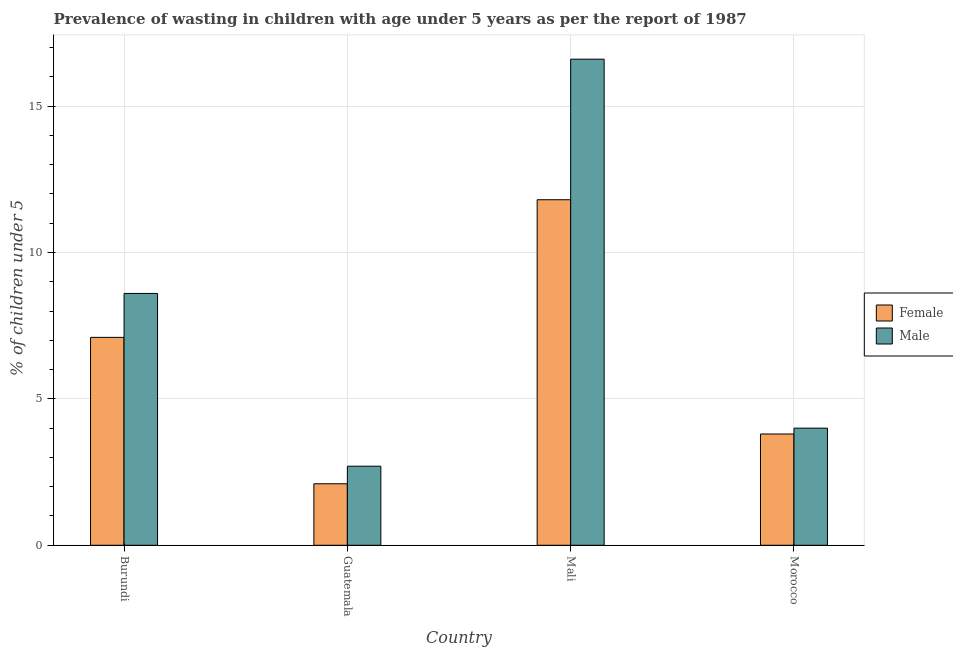How many groups of bars are there?
Provide a succinct answer. 4. Are the number of bars on each tick of the X-axis equal?
Keep it short and to the point. Yes. What is the label of the 2nd group of bars from the left?
Keep it short and to the point. Guatemala. In how many cases, is the number of bars for a given country not equal to the number of legend labels?
Offer a terse response. 0. What is the percentage of undernourished male children in Burundi?
Offer a very short reply. 8.6. Across all countries, what is the maximum percentage of undernourished male children?
Your answer should be compact. 16.6. Across all countries, what is the minimum percentage of undernourished female children?
Provide a short and direct response. 2.1. In which country was the percentage of undernourished female children maximum?
Your answer should be very brief. Mali. In which country was the percentage of undernourished female children minimum?
Offer a very short reply. Guatemala. What is the total percentage of undernourished female children in the graph?
Your answer should be compact. 24.8. What is the difference between the percentage of undernourished female children in Burundi and that in Morocco?
Make the answer very short. 3.3. What is the difference between the percentage of undernourished male children in Mali and the percentage of undernourished female children in Morocco?
Your answer should be compact. 12.8. What is the average percentage of undernourished male children per country?
Your answer should be compact. 7.98. What is the difference between the percentage of undernourished male children and percentage of undernourished female children in Morocco?
Keep it short and to the point. 0.2. In how many countries, is the percentage of undernourished female children greater than 10 %?
Provide a succinct answer. 1. What is the ratio of the percentage of undernourished male children in Burundi to that in Guatemala?
Your answer should be compact. 3.19. What is the difference between the highest and the second highest percentage of undernourished male children?
Give a very brief answer. 8. What is the difference between the highest and the lowest percentage of undernourished female children?
Keep it short and to the point. 9.7. Is the sum of the percentage of undernourished male children in Guatemala and Mali greater than the maximum percentage of undernourished female children across all countries?
Provide a succinct answer. Yes. What does the 1st bar from the right in Morocco represents?
Your answer should be compact. Male. How many bars are there?
Your response must be concise. 8. Are all the bars in the graph horizontal?
Give a very brief answer. No. What is the difference between two consecutive major ticks on the Y-axis?
Provide a succinct answer. 5. Are the values on the major ticks of Y-axis written in scientific E-notation?
Ensure brevity in your answer.  No. Does the graph contain any zero values?
Keep it short and to the point. No. Does the graph contain grids?
Your answer should be very brief. Yes. How many legend labels are there?
Ensure brevity in your answer.  2. What is the title of the graph?
Your response must be concise. Prevalence of wasting in children with age under 5 years as per the report of 1987. Does "Commercial bank branches" appear as one of the legend labels in the graph?
Your response must be concise. No. What is the label or title of the X-axis?
Keep it short and to the point. Country. What is the label or title of the Y-axis?
Ensure brevity in your answer.   % of children under 5. What is the  % of children under 5 in Female in Burundi?
Offer a very short reply. 7.1. What is the  % of children under 5 in Male in Burundi?
Offer a very short reply. 8.6. What is the  % of children under 5 of Female in Guatemala?
Make the answer very short. 2.1. What is the  % of children under 5 of Male in Guatemala?
Offer a very short reply. 2.7. What is the  % of children under 5 of Female in Mali?
Provide a short and direct response. 11.8. What is the  % of children under 5 in Male in Mali?
Provide a succinct answer. 16.6. What is the  % of children under 5 in Female in Morocco?
Make the answer very short. 3.8. What is the  % of children under 5 of Male in Morocco?
Keep it short and to the point. 4. Across all countries, what is the maximum  % of children under 5 of Female?
Give a very brief answer. 11.8. Across all countries, what is the maximum  % of children under 5 in Male?
Your response must be concise. 16.6. Across all countries, what is the minimum  % of children under 5 in Female?
Your answer should be compact. 2.1. Across all countries, what is the minimum  % of children under 5 in Male?
Offer a terse response. 2.7. What is the total  % of children under 5 in Female in the graph?
Provide a succinct answer. 24.8. What is the total  % of children under 5 in Male in the graph?
Give a very brief answer. 31.9. What is the difference between the  % of children under 5 of Female in Burundi and that in Guatemala?
Keep it short and to the point. 5. What is the difference between the  % of children under 5 of Male in Burundi and that in Guatemala?
Your answer should be compact. 5.9. What is the difference between the  % of children under 5 of Female in Burundi and that in Morocco?
Your answer should be very brief. 3.3. What is the difference between the  % of children under 5 of Male in Burundi and that in Morocco?
Your response must be concise. 4.6. What is the difference between the  % of children under 5 of Female in Guatemala and that in Mali?
Ensure brevity in your answer.  -9.7. What is the difference between the  % of children under 5 of Female in Guatemala and that in Morocco?
Provide a short and direct response. -1.7. What is the difference between the  % of children under 5 of Female in Guatemala and the  % of children under 5 of Male in Mali?
Your answer should be compact. -14.5. What is the difference between the  % of children under 5 in Female in Mali and the  % of children under 5 in Male in Morocco?
Ensure brevity in your answer.  7.8. What is the average  % of children under 5 in Male per country?
Your response must be concise. 7.97. What is the difference between the  % of children under 5 of Female and  % of children under 5 of Male in Guatemala?
Keep it short and to the point. -0.6. What is the ratio of the  % of children under 5 of Female in Burundi to that in Guatemala?
Ensure brevity in your answer.  3.38. What is the ratio of the  % of children under 5 of Male in Burundi to that in Guatemala?
Keep it short and to the point. 3.19. What is the ratio of the  % of children under 5 of Female in Burundi to that in Mali?
Provide a short and direct response. 0.6. What is the ratio of the  % of children under 5 of Male in Burundi to that in Mali?
Your answer should be compact. 0.52. What is the ratio of the  % of children under 5 in Female in Burundi to that in Morocco?
Your response must be concise. 1.87. What is the ratio of the  % of children under 5 of Male in Burundi to that in Morocco?
Your answer should be compact. 2.15. What is the ratio of the  % of children under 5 of Female in Guatemala to that in Mali?
Offer a terse response. 0.18. What is the ratio of the  % of children under 5 in Male in Guatemala to that in Mali?
Keep it short and to the point. 0.16. What is the ratio of the  % of children under 5 in Female in Guatemala to that in Morocco?
Provide a short and direct response. 0.55. What is the ratio of the  % of children under 5 in Male in Guatemala to that in Morocco?
Keep it short and to the point. 0.68. What is the ratio of the  % of children under 5 of Female in Mali to that in Morocco?
Provide a succinct answer. 3.11. What is the ratio of the  % of children under 5 in Male in Mali to that in Morocco?
Your answer should be compact. 4.15. What is the difference between the highest and the second highest  % of children under 5 of Female?
Provide a short and direct response. 4.7. What is the difference between the highest and the lowest  % of children under 5 in Male?
Provide a succinct answer. 13.9. 